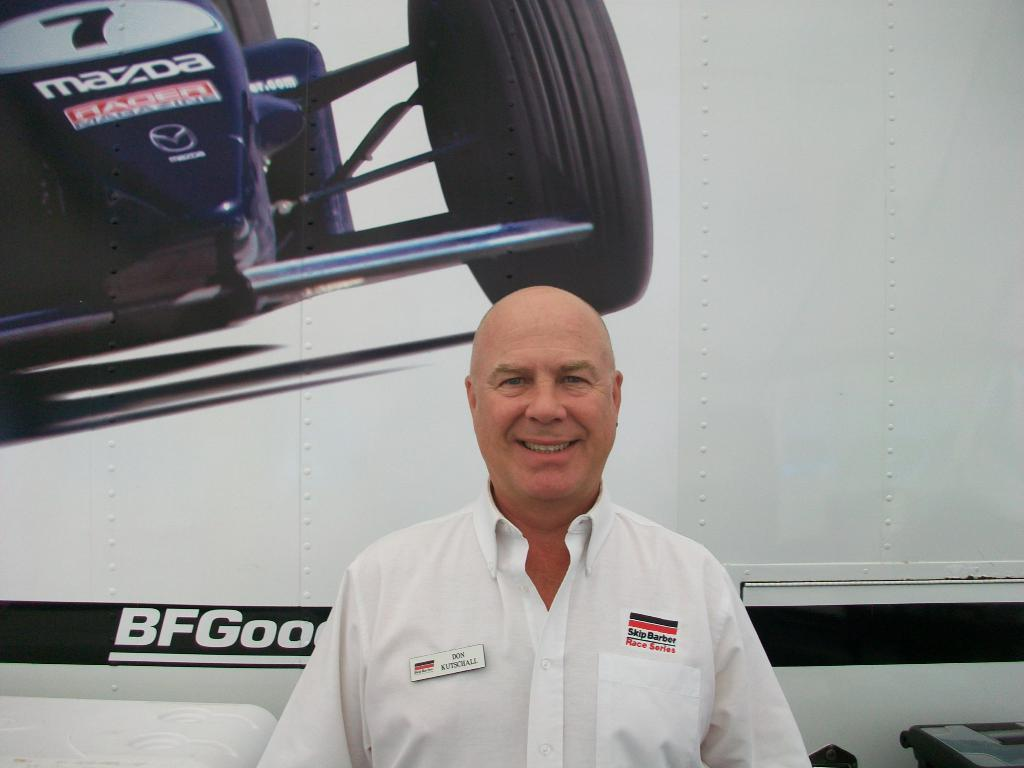<image>
Offer a succinct explanation of the picture presented. Don Kutschall standing infront of a racecar image 